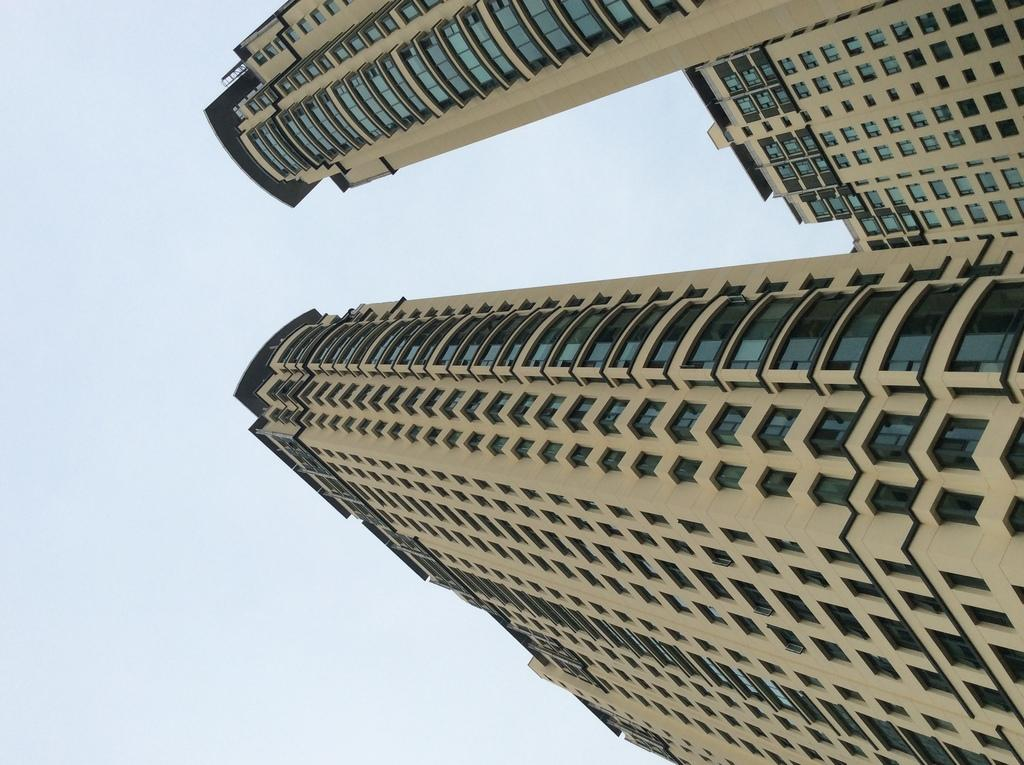What type of buildings can be seen on the right side of the image? There are buildings with glass windows on the right side of the image. What can be seen in the sky in the background of the image? There are clouds in the sky in the background of the image. How many mailboxes are attached to the buildings in the image? There is no information about mailboxes in the image, so we cannot determine their number. 